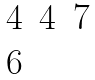<formula> <loc_0><loc_0><loc_500><loc_500>\begin{matrix} 4 & 4 & 7 \\ 6 \end{matrix}</formula> 